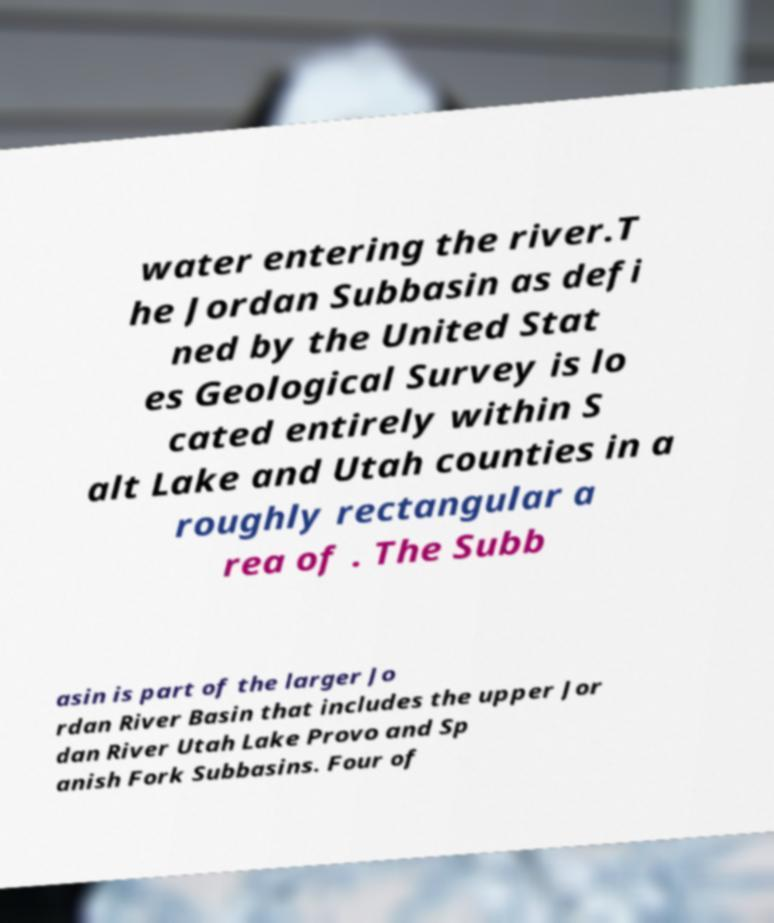Can you accurately transcribe the text from the provided image for me? water entering the river.T he Jordan Subbasin as defi ned by the United Stat es Geological Survey is lo cated entirely within S alt Lake and Utah counties in a roughly rectangular a rea of . The Subb asin is part of the larger Jo rdan River Basin that includes the upper Jor dan River Utah Lake Provo and Sp anish Fork Subbasins. Four of 